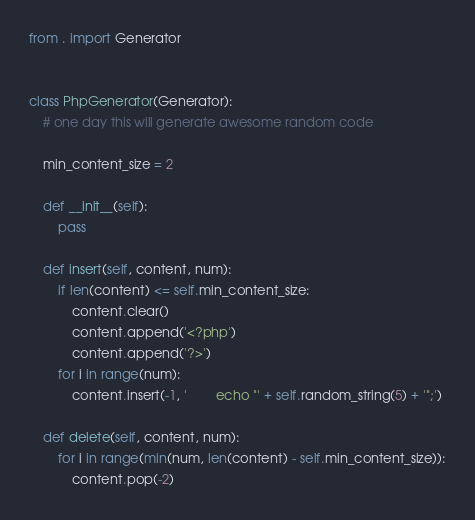<code> <loc_0><loc_0><loc_500><loc_500><_Python_>from . import Generator


class PhpGenerator(Generator):
    # one day this will generate awesome random code

    min_content_size = 2

    def __init__(self):
        pass

    def insert(self, content, num):
        if len(content) <= self.min_content_size:
            content.clear()
            content.append('<?php')
            content.append('?>')
        for i in range(num):
            content.insert(-1, '        echo "' + self.random_string(5) + '";')

    def delete(self, content, num):
        for i in range(min(num, len(content) - self.min_content_size)):
            content.pop(-2)
</code> 